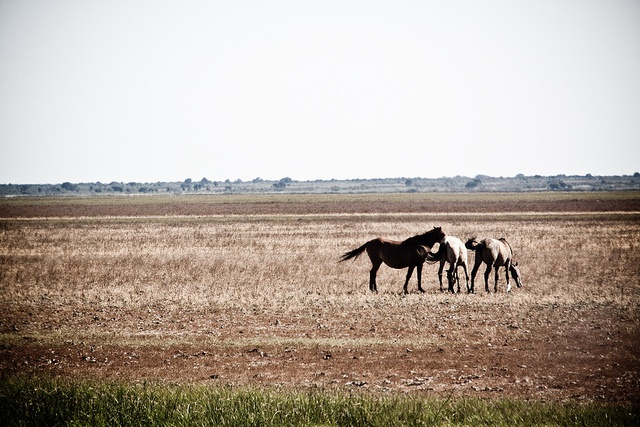Describe the objects in this image and their specific colors. I can see horse in darkgray, black, tan, and gray tones, horse in darkgray, black, lightgray, and tan tones, and horse in darkgray, black, white, gray, and tan tones in this image. 